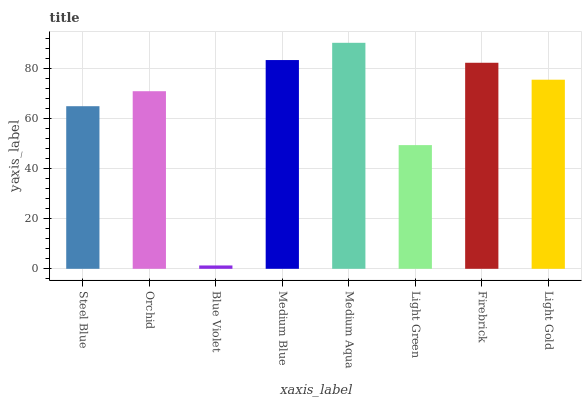Is Blue Violet the minimum?
Answer yes or no. Yes. Is Medium Aqua the maximum?
Answer yes or no. Yes. Is Orchid the minimum?
Answer yes or no. No. Is Orchid the maximum?
Answer yes or no. No. Is Orchid greater than Steel Blue?
Answer yes or no. Yes. Is Steel Blue less than Orchid?
Answer yes or no. Yes. Is Steel Blue greater than Orchid?
Answer yes or no. No. Is Orchid less than Steel Blue?
Answer yes or no. No. Is Light Gold the high median?
Answer yes or no. Yes. Is Orchid the low median?
Answer yes or no. Yes. Is Medium Blue the high median?
Answer yes or no. No. Is Light Gold the low median?
Answer yes or no. No. 